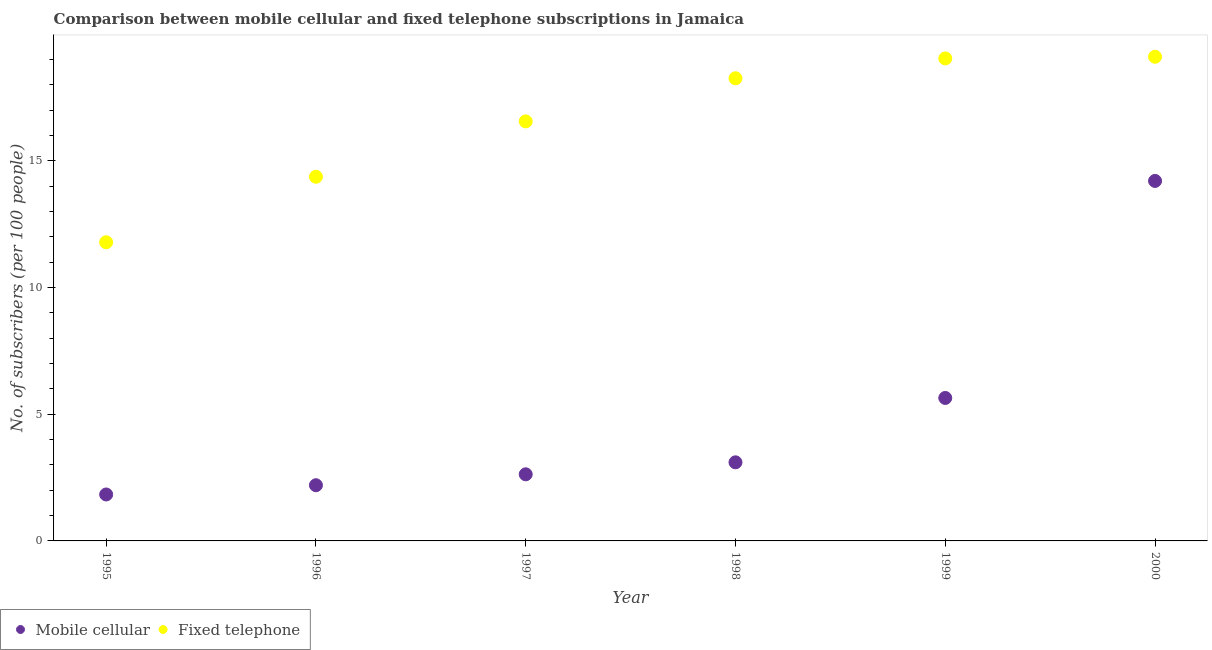How many different coloured dotlines are there?
Offer a very short reply. 2. Is the number of dotlines equal to the number of legend labels?
Keep it short and to the point. Yes. What is the number of fixed telephone subscribers in 1995?
Offer a terse response. 11.79. Across all years, what is the maximum number of mobile cellular subscribers?
Keep it short and to the point. 14.21. Across all years, what is the minimum number of mobile cellular subscribers?
Your answer should be very brief. 1.83. In which year was the number of fixed telephone subscribers maximum?
Offer a terse response. 2000. In which year was the number of mobile cellular subscribers minimum?
Give a very brief answer. 1995. What is the total number of fixed telephone subscribers in the graph?
Your answer should be very brief. 99.15. What is the difference between the number of mobile cellular subscribers in 1999 and that in 2000?
Your answer should be very brief. -8.57. What is the difference between the number of mobile cellular subscribers in 1997 and the number of fixed telephone subscribers in 1996?
Your answer should be very brief. -11.75. What is the average number of mobile cellular subscribers per year?
Provide a short and direct response. 4.94. In the year 1995, what is the difference between the number of fixed telephone subscribers and number of mobile cellular subscribers?
Provide a short and direct response. 9.96. In how many years, is the number of fixed telephone subscribers greater than 10?
Make the answer very short. 6. What is the ratio of the number of fixed telephone subscribers in 1997 to that in 1999?
Your response must be concise. 0.87. What is the difference between the highest and the second highest number of fixed telephone subscribers?
Keep it short and to the point. 0.07. What is the difference between the highest and the lowest number of fixed telephone subscribers?
Offer a very short reply. 7.32. In how many years, is the number of fixed telephone subscribers greater than the average number of fixed telephone subscribers taken over all years?
Your response must be concise. 4. Does the number of fixed telephone subscribers monotonically increase over the years?
Give a very brief answer. Yes. Is the number of fixed telephone subscribers strictly less than the number of mobile cellular subscribers over the years?
Keep it short and to the point. No. How many dotlines are there?
Provide a short and direct response. 2. How many years are there in the graph?
Give a very brief answer. 6. Does the graph contain any zero values?
Ensure brevity in your answer.  No. How many legend labels are there?
Your answer should be very brief. 2. What is the title of the graph?
Your answer should be very brief. Comparison between mobile cellular and fixed telephone subscriptions in Jamaica. What is the label or title of the Y-axis?
Offer a terse response. No. of subscribers (per 100 people). What is the No. of subscribers (per 100 people) of Mobile cellular in 1995?
Offer a very short reply. 1.83. What is the No. of subscribers (per 100 people) of Fixed telephone in 1995?
Offer a very short reply. 11.79. What is the No. of subscribers (per 100 people) in Mobile cellular in 1996?
Provide a short and direct response. 2.2. What is the No. of subscribers (per 100 people) in Fixed telephone in 1996?
Offer a very short reply. 14.38. What is the No. of subscribers (per 100 people) of Mobile cellular in 1997?
Offer a terse response. 2.63. What is the No. of subscribers (per 100 people) in Fixed telephone in 1997?
Offer a very short reply. 16.56. What is the No. of subscribers (per 100 people) in Mobile cellular in 1998?
Offer a very short reply. 3.1. What is the No. of subscribers (per 100 people) of Fixed telephone in 1998?
Offer a terse response. 18.26. What is the No. of subscribers (per 100 people) in Mobile cellular in 1999?
Your answer should be compact. 5.64. What is the No. of subscribers (per 100 people) in Fixed telephone in 1999?
Offer a very short reply. 19.05. What is the No. of subscribers (per 100 people) in Mobile cellular in 2000?
Give a very brief answer. 14.21. What is the No. of subscribers (per 100 people) of Fixed telephone in 2000?
Your answer should be very brief. 19.11. Across all years, what is the maximum No. of subscribers (per 100 people) in Mobile cellular?
Give a very brief answer. 14.21. Across all years, what is the maximum No. of subscribers (per 100 people) of Fixed telephone?
Offer a very short reply. 19.11. Across all years, what is the minimum No. of subscribers (per 100 people) in Mobile cellular?
Ensure brevity in your answer.  1.83. Across all years, what is the minimum No. of subscribers (per 100 people) in Fixed telephone?
Your answer should be compact. 11.79. What is the total No. of subscribers (per 100 people) in Mobile cellular in the graph?
Your answer should be very brief. 29.62. What is the total No. of subscribers (per 100 people) of Fixed telephone in the graph?
Give a very brief answer. 99.15. What is the difference between the No. of subscribers (per 100 people) in Mobile cellular in 1995 and that in 1996?
Offer a very short reply. -0.37. What is the difference between the No. of subscribers (per 100 people) of Fixed telephone in 1995 and that in 1996?
Give a very brief answer. -2.59. What is the difference between the No. of subscribers (per 100 people) in Mobile cellular in 1995 and that in 1997?
Your response must be concise. -0.8. What is the difference between the No. of subscribers (per 100 people) in Fixed telephone in 1995 and that in 1997?
Keep it short and to the point. -4.77. What is the difference between the No. of subscribers (per 100 people) in Mobile cellular in 1995 and that in 1998?
Your answer should be very brief. -1.27. What is the difference between the No. of subscribers (per 100 people) of Fixed telephone in 1995 and that in 1998?
Your answer should be compact. -6.47. What is the difference between the No. of subscribers (per 100 people) in Mobile cellular in 1995 and that in 1999?
Keep it short and to the point. -3.81. What is the difference between the No. of subscribers (per 100 people) of Fixed telephone in 1995 and that in 1999?
Provide a succinct answer. -7.26. What is the difference between the No. of subscribers (per 100 people) of Mobile cellular in 1995 and that in 2000?
Ensure brevity in your answer.  -12.38. What is the difference between the No. of subscribers (per 100 people) of Fixed telephone in 1995 and that in 2000?
Provide a succinct answer. -7.32. What is the difference between the No. of subscribers (per 100 people) of Mobile cellular in 1996 and that in 1997?
Offer a very short reply. -0.43. What is the difference between the No. of subscribers (per 100 people) in Fixed telephone in 1996 and that in 1997?
Keep it short and to the point. -2.19. What is the difference between the No. of subscribers (per 100 people) in Mobile cellular in 1996 and that in 1998?
Your answer should be compact. -0.9. What is the difference between the No. of subscribers (per 100 people) of Fixed telephone in 1996 and that in 1998?
Ensure brevity in your answer.  -3.89. What is the difference between the No. of subscribers (per 100 people) in Mobile cellular in 1996 and that in 1999?
Your answer should be very brief. -3.44. What is the difference between the No. of subscribers (per 100 people) in Fixed telephone in 1996 and that in 1999?
Provide a succinct answer. -4.67. What is the difference between the No. of subscribers (per 100 people) of Mobile cellular in 1996 and that in 2000?
Offer a very short reply. -12.01. What is the difference between the No. of subscribers (per 100 people) in Fixed telephone in 1996 and that in 2000?
Your answer should be very brief. -4.74. What is the difference between the No. of subscribers (per 100 people) of Mobile cellular in 1997 and that in 1998?
Make the answer very short. -0.47. What is the difference between the No. of subscribers (per 100 people) in Fixed telephone in 1997 and that in 1998?
Your answer should be very brief. -1.7. What is the difference between the No. of subscribers (per 100 people) in Mobile cellular in 1997 and that in 1999?
Ensure brevity in your answer.  -3.01. What is the difference between the No. of subscribers (per 100 people) of Fixed telephone in 1997 and that in 1999?
Your answer should be compact. -2.48. What is the difference between the No. of subscribers (per 100 people) of Mobile cellular in 1997 and that in 2000?
Keep it short and to the point. -11.58. What is the difference between the No. of subscribers (per 100 people) in Fixed telephone in 1997 and that in 2000?
Give a very brief answer. -2.55. What is the difference between the No. of subscribers (per 100 people) in Mobile cellular in 1998 and that in 1999?
Ensure brevity in your answer.  -2.54. What is the difference between the No. of subscribers (per 100 people) of Fixed telephone in 1998 and that in 1999?
Offer a terse response. -0.78. What is the difference between the No. of subscribers (per 100 people) in Mobile cellular in 1998 and that in 2000?
Your response must be concise. -11.11. What is the difference between the No. of subscribers (per 100 people) in Fixed telephone in 1998 and that in 2000?
Make the answer very short. -0.85. What is the difference between the No. of subscribers (per 100 people) in Mobile cellular in 1999 and that in 2000?
Make the answer very short. -8.57. What is the difference between the No. of subscribers (per 100 people) in Fixed telephone in 1999 and that in 2000?
Make the answer very short. -0.07. What is the difference between the No. of subscribers (per 100 people) in Mobile cellular in 1995 and the No. of subscribers (per 100 people) in Fixed telephone in 1996?
Your answer should be very brief. -12.54. What is the difference between the No. of subscribers (per 100 people) in Mobile cellular in 1995 and the No. of subscribers (per 100 people) in Fixed telephone in 1997?
Ensure brevity in your answer.  -14.73. What is the difference between the No. of subscribers (per 100 people) in Mobile cellular in 1995 and the No. of subscribers (per 100 people) in Fixed telephone in 1998?
Give a very brief answer. -16.43. What is the difference between the No. of subscribers (per 100 people) in Mobile cellular in 1995 and the No. of subscribers (per 100 people) in Fixed telephone in 1999?
Your answer should be compact. -17.21. What is the difference between the No. of subscribers (per 100 people) of Mobile cellular in 1995 and the No. of subscribers (per 100 people) of Fixed telephone in 2000?
Your answer should be compact. -17.28. What is the difference between the No. of subscribers (per 100 people) of Mobile cellular in 1996 and the No. of subscribers (per 100 people) of Fixed telephone in 1997?
Your answer should be compact. -14.36. What is the difference between the No. of subscribers (per 100 people) in Mobile cellular in 1996 and the No. of subscribers (per 100 people) in Fixed telephone in 1998?
Provide a short and direct response. -16.07. What is the difference between the No. of subscribers (per 100 people) in Mobile cellular in 1996 and the No. of subscribers (per 100 people) in Fixed telephone in 1999?
Make the answer very short. -16.85. What is the difference between the No. of subscribers (per 100 people) of Mobile cellular in 1996 and the No. of subscribers (per 100 people) of Fixed telephone in 2000?
Provide a short and direct response. -16.91. What is the difference between the No. of subscribers (per 100 people) in Mobile cellular in 1997 and the No. of subscribers (per 100 people) in Fixed telephone in 1998?
Offer a very short reply. -15.63. What is the difference between the No. of subscribers (per 100 people) of Mobile cellular in 1997 and the No. of subscribers (per 100 people) of Fixed telephone in 1999?
Keep it short and to the point. -16.42. What is the difference between the No. of subscribers (per 100 people) of Mobile cellular in 1997 and the No. of subscribers (per 100 people) of Fixed telephone in 2000?
Offer a terse response. -16.48. What is the difference between the No. of subscribers (per 100 people) of Mobile cellular in 1998 and the No. of subscribers (per 100 people) of Fixed telephone in 1999?
Keep it short and to the point. -15.94. What is the difference between the No. of subscribers (per 100 people) of Mobile cellular in 1998 and the No. of subscribers (per 100 people) of Fixed telephone in 2000?
Offer a terse response. -16.01. What is the difference between the No. of subscribers (per 100 people) of Mobile cellular in 1999 and the No. of subscribers (per 100 people) of Fixed telephone in 2000?
Your answer should be very brief. -13.47. What is the average No. of subscribers (per 100 people) in Mobile cellular per year?
Provide a succinct answer. 4.94. What is the average No. of subscribers (per 100 people) in Fixed telephone per year?
Your response must be concise. 16.52. In the year 1995, what is the difference between the No. of subscribers (per 100 people) of Mobile cellular and No. of subscribers (per 100 people) of Fixed telephone?
Keep it short and to the point. -9.96. In the year 1996, what is the difference between the No. of subscribers (per 100 people) of Mobile cellular and No. of subscribers (per 100 people) of Fixed telephone?
Your answer should be very brief. -12.18. In the year 1997, what is the difference between the No. of subscribers (per 100 people) in Mobile cellular and No. of subscribers (per 100 people) in Fixed telephone?
Give a very brief answer. -13.93. In the year 1998, what is the difference between the No. of subscribers (per 100 people) of Mobile cellular and No. of subscribers (per 100 people) of Fixed telephone?
Keep it short and to the point. -15.16. In the year 1999, what is the difference between the No. of subscribers (per 100 people) in Mobile cellular and No. of subscribers (per 100 people) in Fixed telephone?
Your response must be concise. -13.4. In the year 2000, what is the difference between the No. of subscribers (per 100 people) of Mobile cellular and No. of subscribers (per 100 people) of Fixed telephone?
Make the answer very short. -4.9. What is the ratio of the No. of subscribers (per 100 people) of Mobile cellular in 1995 to that in 1996?
Your answer should be very brief. 0.83. What is the ratio of the No. of subscribers (per 100 people) in Fixed telephone in 1995 to that in 1996?
Keep it short and to the point. 0.82. What is the ratio of the No. of subscribers (per 100 people) of Mobile cellular in 1995 to that in 1997?
Provide a short and direct response. 0.7. What is the ratio of the No. of subscribers (per 100 people) in Fixed telephone in 1995 to that in 1997?
Provide a short and direct response. 0.71. What is the ratio of the No. of subscribers (per 100 people) of Mobile cellular in 1995 to that in 1998?
Your response must be concise. 0.59. What is the ratio of the No. of subscribers (per 100 people) of Fixed telephone in 1995 to that in 1998?
Ensure brevity in your answer.  0.65. What is the ratio of the No. of subscribers (per 100 people) of Mobile cellular in 1995 to that in 1999?
Give a very brief answer. 0.32. What is the ratio of the No. of subscribers (per 100 people) of Fixed telephone in 1995 to that in 1999?
Keep it short and to the point. 0.62. What is the ratio of the No. of subscribers (per 100 people) of Mobile cellular in 1995 to that in 2000?
Offer a very short reply. 0.13. What is the ratio of the No. of subscribers (per 100 people) of Fixed telephone in 1995 to that in 2000?
Offer a terse response. 0.62. What is the ratio of the No. of subscribers (per 100 people) of Mobile cellular in 1996 to that in 1997?
Your answer should be very brief. 0.84. What is the ratio of the No. of subscribers (per 100 people) in Fixed telephone in 1996 to that in 1997?
Your answer should be compact. 0.87. What is the ratio of the No. of subscribers (per 100 people) of Mobile cellular in 1996 to that in 1998?
Provide a short and direct response. 0.71. What is the ratio of the No. of subscribers (per 100 people) of Fixed telephone in 1996 to that in 1998?
Offer a terse response. 0.79. What is the ratio of the No. of subscribers (per 100 people) in Mobile cellular in 1996 to that in 1999?
Keep it short and to the point. 0.39. What is the ratio of the No. of subscribers (per 100 people) in Fixed telephone in 1996 to that in 1999?
Give a very brief answer. 0.75. What is the ratio of the No. of subscribers (per 100 people) of Mobile cellular in 1996 to that in 2000?
Offer a very short reply. 0.15. What is the ratio of the No. of subscribers (per 100 people) of Fixed telephone in 1996 to that in 2000?
Your response must be concise. 0.75. What is the ratio of the No. of subscribers (per 100 people) in Mobile cellular in 1997 to that in 1998?
Provide a succinct answer. 0.85. What is the ratio of the No. of subscribers (per 100 people) in Fixed telephone in 1997 to that in 1998?
Make the answer very short. 0.91. What is the ratio of the No. of subscribers (per 100 people) in Mobile cellular in 1997 to that in 1999?
Provide a succinct answer. 0.47. What is the ratio of the No. of subscribers (per 100 people) in Fixed telephone in 1997 to that in 1999?
Provide a succinct answer. 0.87. What is the ratio of the No. of subscribers (per 100 people) of Mobile cellular in 1997 to that in 2000?
Your response must be concise. 0.19. What is the ratio of the No. of subscribers (per 100 people) of Fixed telephone in 1997 to that in 2000?
Give a very brief answer. 0.87. What is the ratio of the No. of subscribers (per 100 people) of Mobile cellular in 1998 to that in 1999?
Make the answer very short. 0.55. What is the ratio of the No. of subscribers (per 100 people) in Fixed telephone in 1998 to that in 1999?
Offer a very short reply. 0.96. What is the ratio of the No. of subscribers (per 100 people) of Mobile cellular in 1998 to that in 2000?
Offer a terse response. 0.22. What is the ratio of the No. of subscribers (per 100 people) of Fixed telephone in 1998 to that in 2000?
Ensure brevity in your answer.  0.96. What is the ratio of the No. of subscribers (per 100 people) in Mobile cellular in 1999 to that in 2000?
Ensure brevity in your answer.  0.4. What is the ratio of the No. of subscribers (per 100 people) of Fixed telephone in 1999 to that in 2000?
Provide a succinct answer. 1. What is the difference between the highest and the second highest No. of subscribers (per 100 people) of Mobile cellular?
Provide a succinct answer. 8.57. What is the difference between the highest and the second highest No. of subscribers (per 100 people) of Fixed telephone?
Offer a terse response. 0.07. What is the difference between the highest and the lowest No. of subscribers (per 100 people) of Mobile cellular?
Make the answer very short. 12.38. What is the difference between the highest and the lowest No. of subscribers (per 100 people) of Fixed telephone?
Your answer should be very brief. 7.32. 